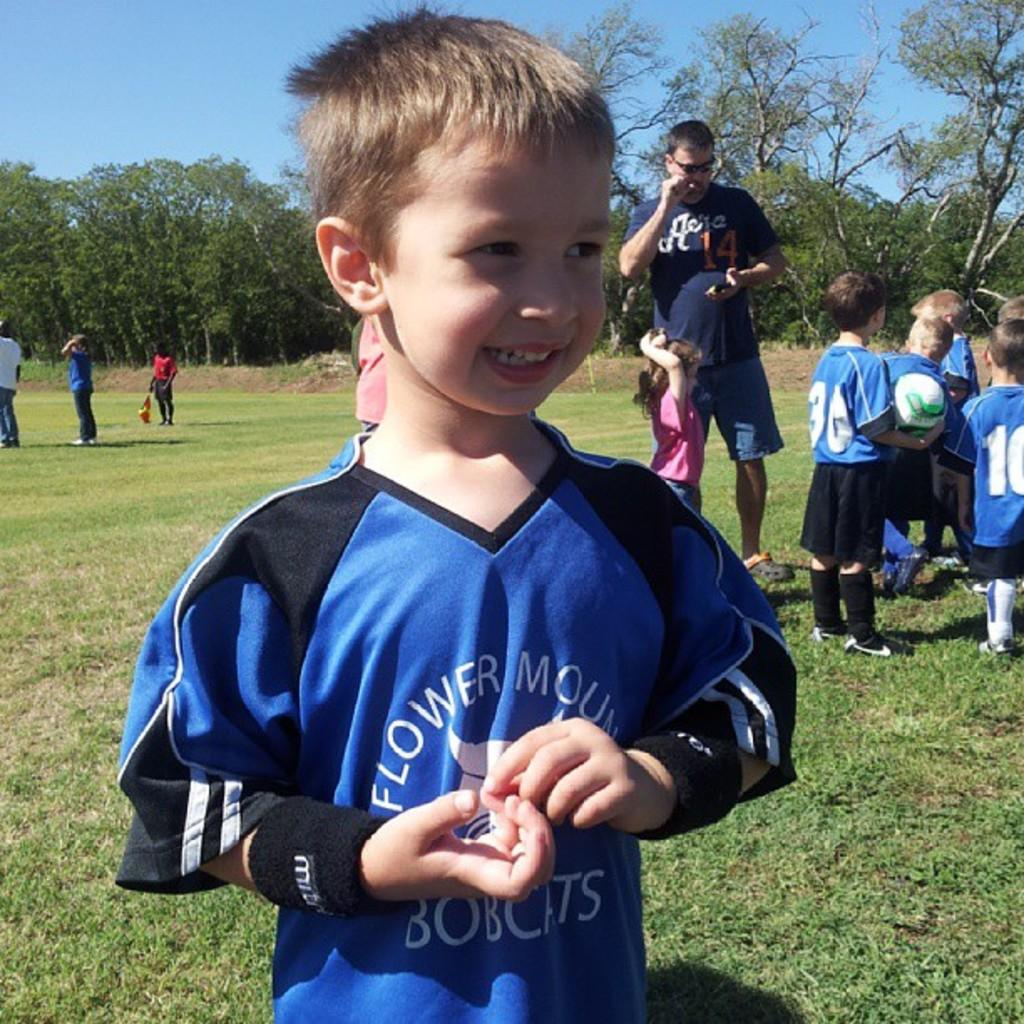<image>
Write a terse but informative summary of the picture. A young boy is sporting a jersey with bobcats on the bottom half of it. 